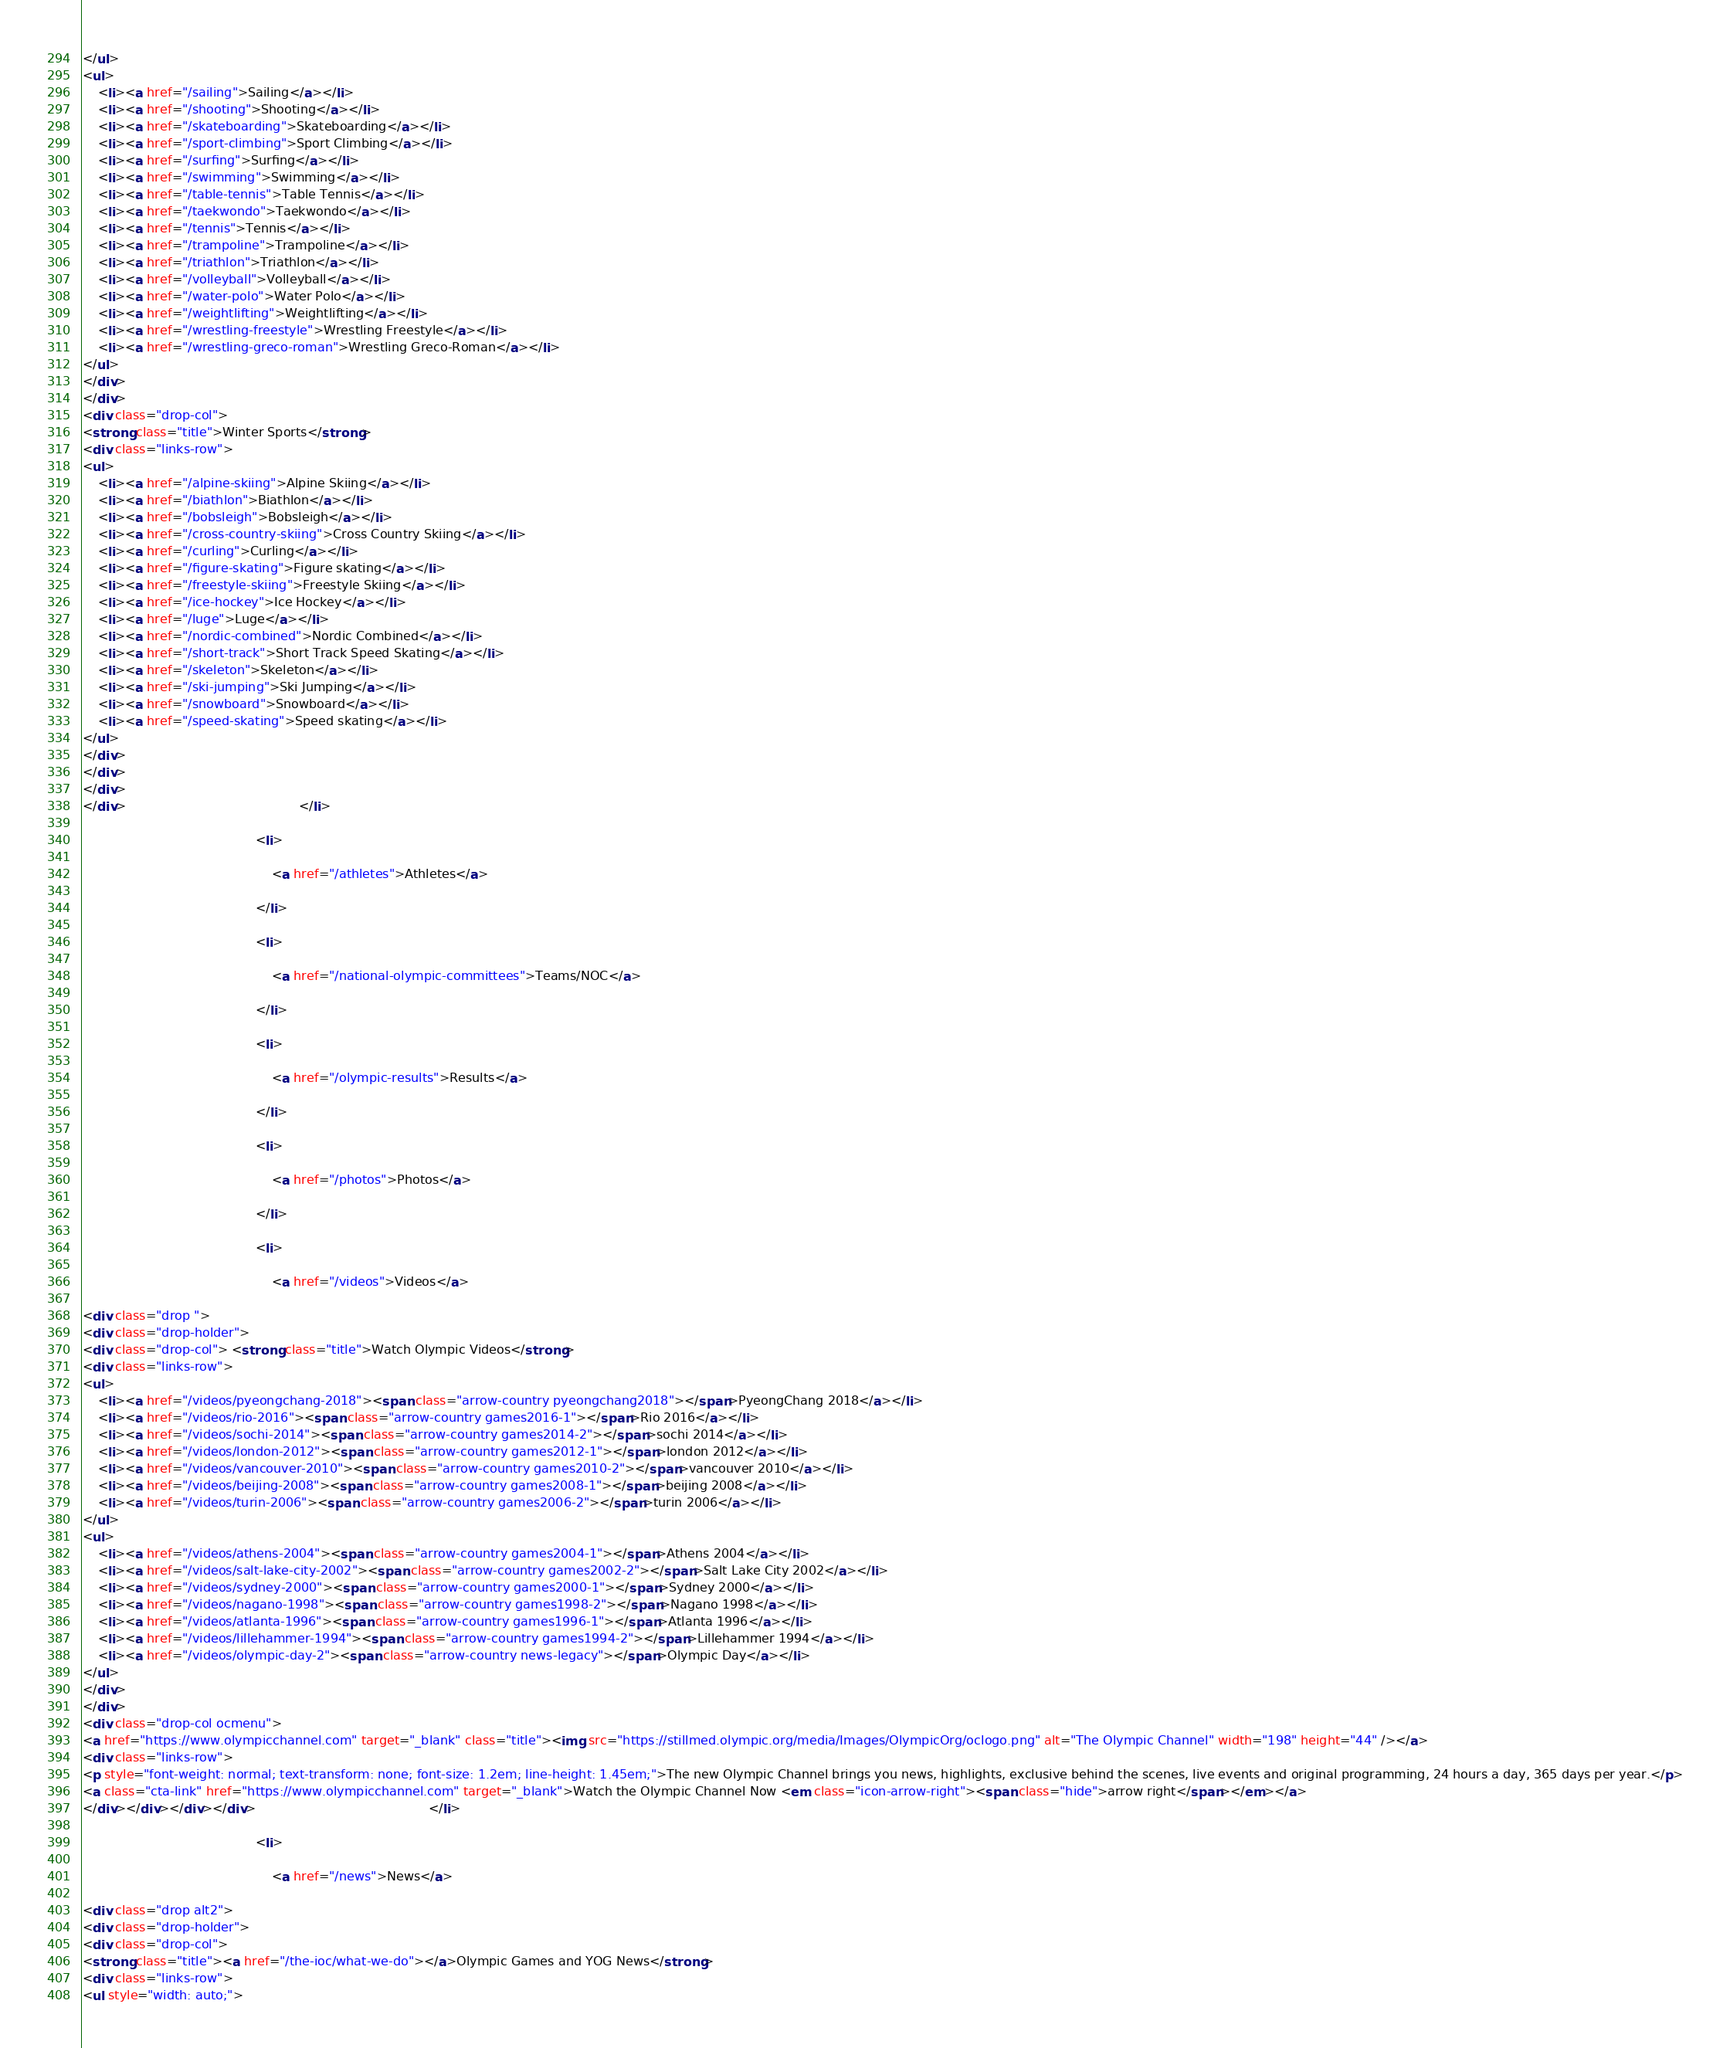Convert code to text. <code><loc_0><loc_0><loc_500><loc_500><_HTML_></ul>
<ul>
    <li><a href="/sailing">Sailing</a></li>
    <li><a href="/shooting">Shooting</a></li>
    <li><a href="/skateboarding">Skateboarding</a></li>
    <li><a href="/sport-climbing">Sport Climbing</a></li>
    <li><a href="/surfing">Surfing</a></li>
    <li><a href="/swimming">Swimming</a></li>
    <li><a href="/table-tennis">Table Tennis</a></li>
    <li><a href="/taekwondo">Taekwondo</a></li>
    <li><a href="/tennis">Tennis</a></li>
    <li><a href="/trampoline">Trampoline</a></li>
    <li><a href="/triathlon">Triathlon</a></li>
    <li><a href="/volleyball">Volleyball</a></li>
    <li><a href="/water-polo">Water Polo</a></li>
    <li><a href="/weightlifting">Weightlifting</a></li>
    <li><a href="/wrestling-freestyle">Wrestling Freestyle</a></li>
    <li><a href="/wrestling-greco-roman">Wrestling Greco-Roman</a></li>
</ul>
</div>
</div>
<div class="drop-col">
<strong class="title">Winter Sports</strong>
<div class="links-row">
<ul>
    <li><a href="/alpine-skiing">Alpine Skiing</a></li>
    <li><a href="/biathlon">Biathlon</a></li>
    <li><a href="/bobsleigh">Bobsleigh</a></li>
    <li><a href="/cross-country-skiing">Cross Country Skiing</a></li>
    <li><a href="/curling">Curling</a></li>
    <li><a href="/figure-skating">Figure skating</a></li>
    <li><a href="/freestyle-skiing">Freestyle Skiing</a></li>
    <li><a href="/ice-hockey">Ice Hockey</a></li>
    <li><a href="/luge">Luge</a></li>
    <li><a href="/nordic-combined">Nordic Combined</a></li>
    <li><a href="/short-track">Short Track Speed Skating</a></li>
    <li><a href="/skeleton">Skeleton</a></li>
    <li><a href="/ski-jumping">Ski Jumping</a></li>
    <li><a href="/snowboard">Snowboard</a></li>
    <li><a href="/speed-skating">Speed skating</a></li>
</ul>
</div>
</div>
</div>
</div>                                            </li>
                                            <li>
                                                <a href="/athletes">Athletes</a>
                                            </li>
                                            <li>
                                                <a href="/national-olympic-committees">Teams/NOC</a>
                                            </li>
                                            <li>
                                                <a href="/olympic-results">Results</a>
                                            </li>
                                            <li>
                                                <a href="/photos">Photos</a>
                                            </li>
                                            <li>
                                                <a href="/videos">Videos</a>
<div class="drop ">
<div class="drop-holder">
<div class="drop-col"> <strong class="title">Watch Olympic Videos</strong>
<div class="links-row">
<ul>
    <li><a href="/videos/pyeongchang-2018"><span class="arrow-country pyeongchang2018"></span>PyeongChang 2018</a></li>
    <li><a href="/videos/rio-2016"><span class="arrow-country games2016-1"></span>Rio 2016</a></li>
    <li><a href="/videos/sochi-2014"><span class="arrow-country games2014-2"></span>sochi 2014</a></li>
    <li><a href="/videos/london-2012"><span class="arrow-country games2012-1"></span>london 2012</a></li>
    <li><a href="/videos/vancouver-2010"><span class="arrow-country games2010-2"></span>vancouver 2010</a></li>
    <li><a href="/videos/beijing-2008"><span class="arrow-country games2008-1"></span>beijing 2008</a></li>
    <li><a href="/videos/turin-2006"><span class="arrow-country games2006-2"></span>turin 2006</a></li>
</ul>
<ul>
    <li><a href="/videos/athens-2004"><span class="arrow-country games2004-1"></span>Athens 2004</a></li>
    <li><a href="/videos/salt-lake-city-2002"><span class="arrow-country games2002-2"></span>Salt Lake City 2002</a></li>
    <li><a href="/videos/sydney-2000"><span class="arrow-country games2000-1"></span>Sydney 2000</a></li>
    <li><a href="/videos/nagano-1998"><span class="arrow-country games1998-2"></span>Nagano 1998</a></li>
    <li><a href="/videos/atlanta-1996"><span class="arrow-country games1996-1"></span>Atlanta 1996</a></li>
    <li><a href="/videos/lillehammer-1994"><span class="arrow-country games1994-2"></span>Lillehammer 1994</a></li>
    <li><a href="/videos/olympic-day-2"><span class="arrow-country news-legacy"></span>Olympic Day</a></li>
</ul>
</div>
</div>
<div class="drop-col ocmenu">
<a href="https://www.olympicchannel.com" target="_blank" class="title"><img src="https://stillmed.olympic.org/media/Images/OlympicOrg/oclogo.png" alt="The Olympic Channel" width="198" height="44" /></a>
<div class="links-row">
<p style="font-weight: normal; text-transform: none; font-size: 1.2em; line-height: 1.45em;">The new Olympic Channel brings you news, highlights, exclusive behind the scenes, live events and original programming, 24 hours a day, 365 days per year.</p>
<a class="cta-link" href="https://www.olympicchannel.com" target="_blank">Watch the Olympic Channel Now <em class="icon-arrow-right"><span class="hide">arrow right</span></em></a>
</div></div></div></div>                                            </li>
                                            <li>
                                                <a href="/news">News</a>
<div class="drop alt2">
<div class="drop-holder">
<div class="drop-col">
<strong class="title"><a href="/the-ioc/what-we-do"></a>Olympic Games and YOG News</strong>
<div class="links-row">
<ul style="width: auto;"></code> 